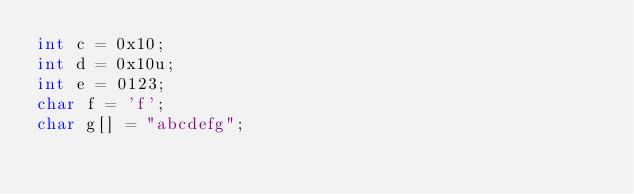<code> <loc_0><loc_0><loc_500><loc_500><_C_>int c = 0x10;
int d = 0x10u;
int e = 0123;
char f = 'f';
char g[] = "abcdefg";
</code> 